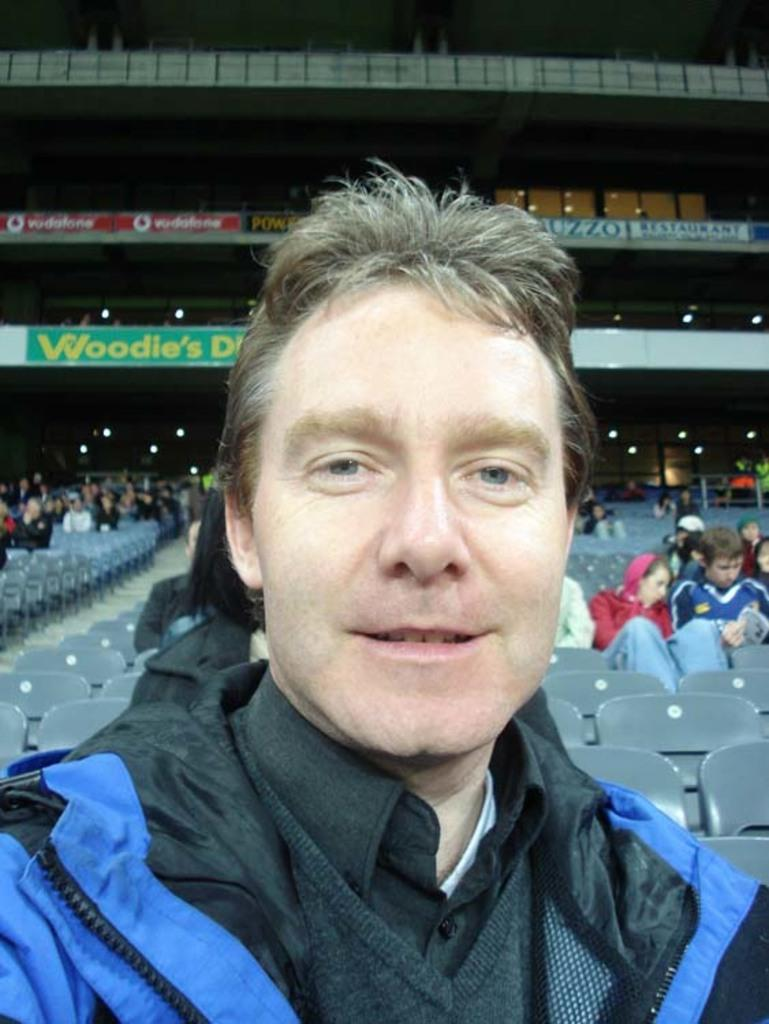What is the main subject in the center of the image? There is a person wearing a jacket in the center of the image. Can you describe the people in the background of the image? There are people sitting in chairs in the background of the image. What type of plant is growing on the floor in the image? There is no plant growing on the floor in the image. What is the person in the center of the image using to stir their drink? There is no stick or any indication of a drink in the image. 